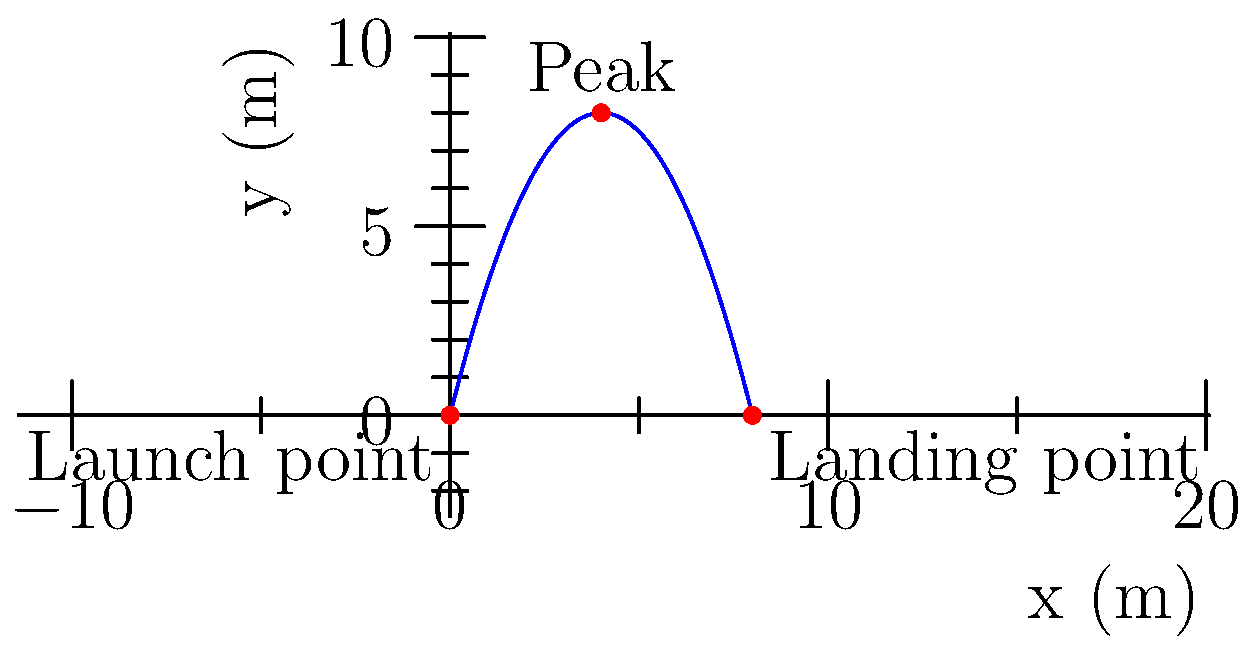In a VR game, you're testing a throwing mechanic where an object follows a parabolic path. The graph shows the trajectory of the thrown object. If the object reaches its peak height at 4 meters horizontally from the launch point, what is the total horizontal distance traveled by the object before it lands? To determine the total horizontal distance traveled by the object, we need to analyze the parabolic trajectory shown in the graph. Let's break it down step-by-step:

1. The parabolic path is symmetrical, with the peak at the center of the horizontal distance.

2. We're given that the object reaches its peak height at 4 meters horizontally from the launch point.

3. Since the peak is at the center of the parabola, the total horizontal distance will be twice the distance to the peak.

4. Therefore, we can calculate the total horizontal distance as:
   Total distance = 2 * (Distance to peak)
   Total distance = 2 * 4 meters
   Total distance = 8 meters

5. We can verify this by observing the graph, which shows the object landing at the 8-meter mark on the x-axis.

This analysis is crucial for a game tester to ensure that the throwing mechanic in the VR game is accurately implemented and behaves as expected.
Answer: 8 meters 